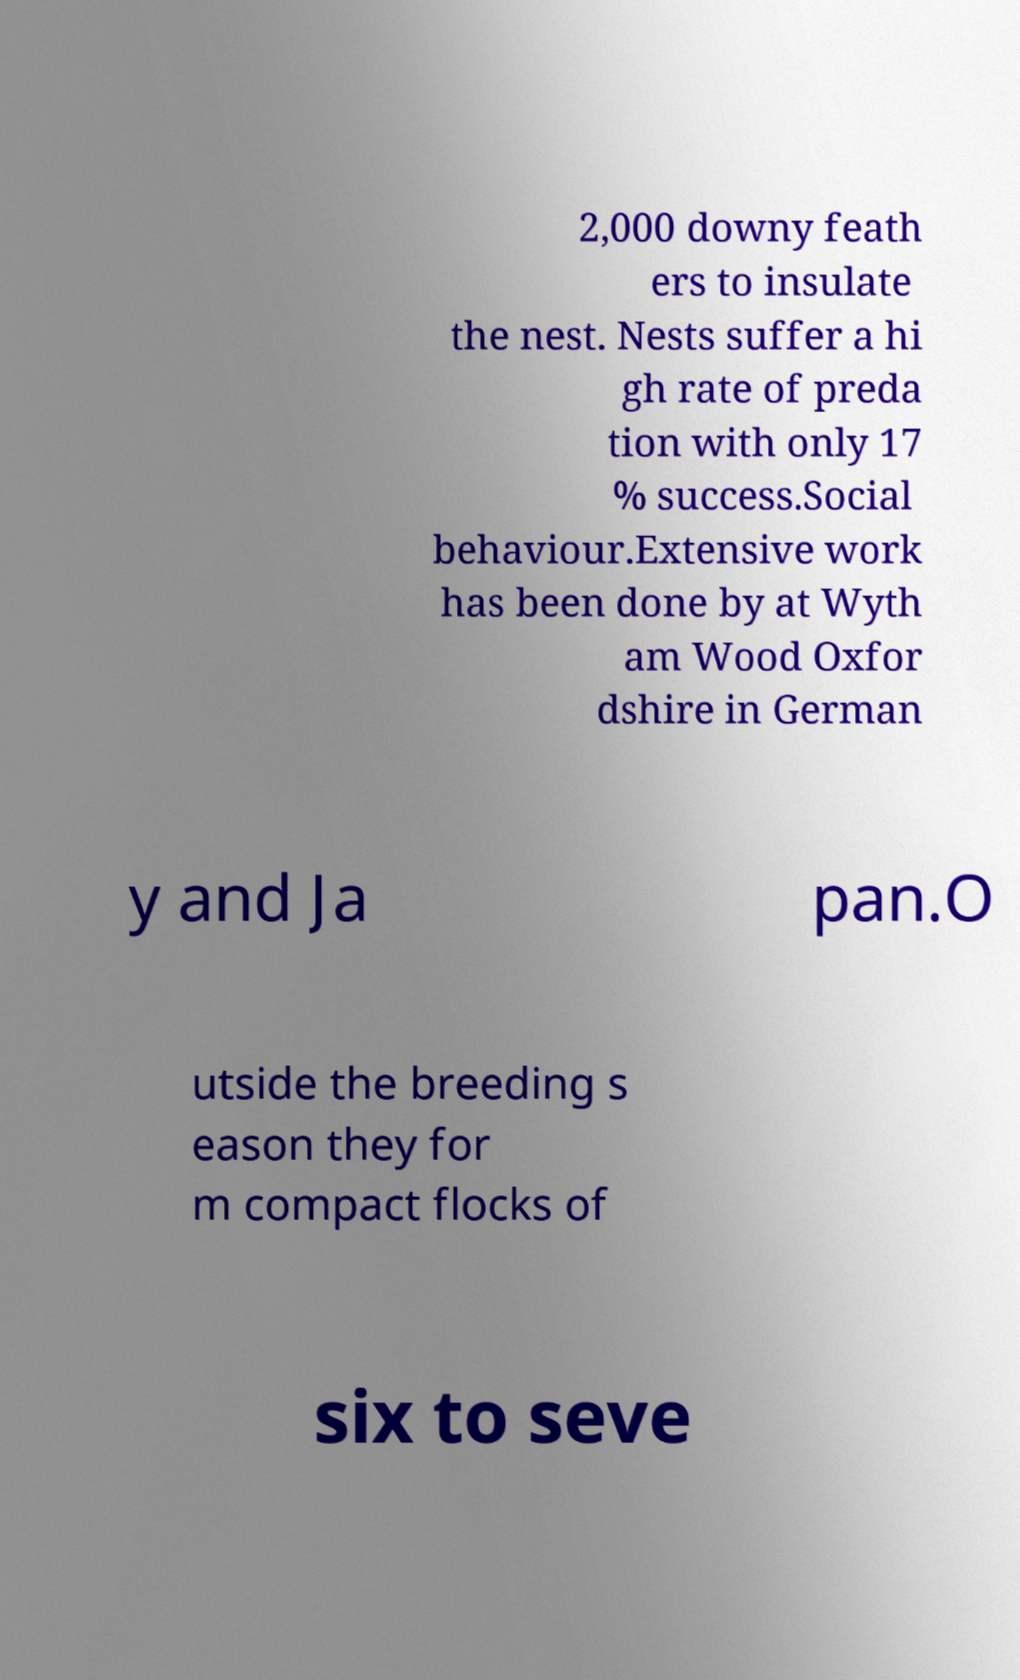Could you extract and type out the text from this image? 2,000 downy feath ers to insulate the nest. Nests suffer a hi gh rate of preda tion with only 17 % success.Social behaviour.Extensive work has been done by at Wyth am Wood Oxfor dshire in German y and Ja pan.O utside the breeding s eason they for m compact flocks of six to seve 